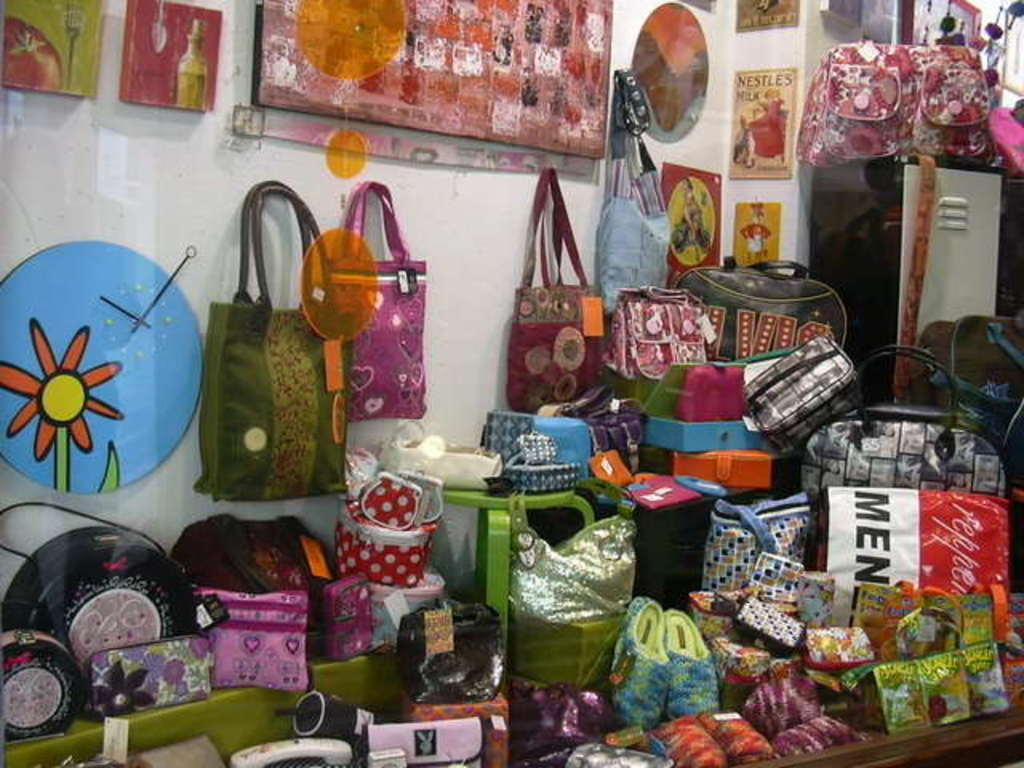What type of objects are on the table in the image? There are bags and purses on the table. Are there any other items visible on the table? Yes, there are other items on the table. How many fingers can be seen wearing mittens in the image? There are no fingers or mittens present in the image. What type of lift is visible in the background of the image? There is no lift visible in the image; it only shows objects on a table. 